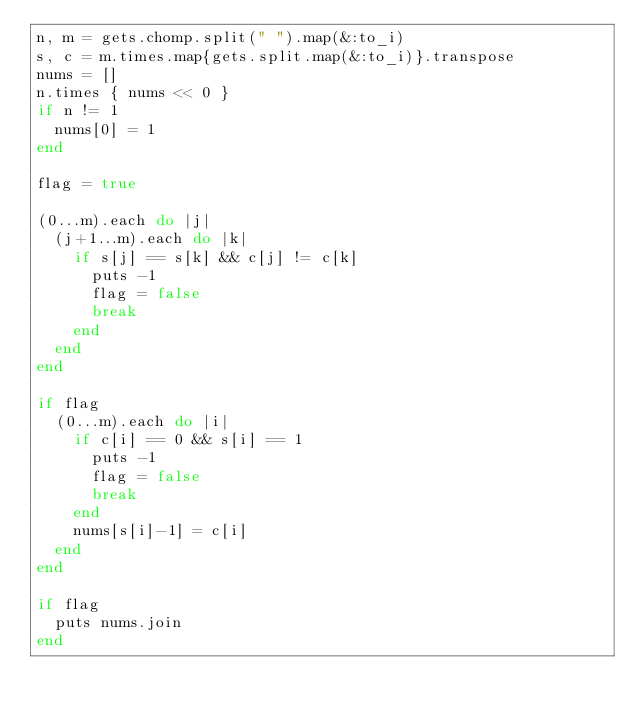<code> <loc_0><loc_0><loc_500><loc_500><_Ruby_>n, m = gets.chomp.split(" ").map(&:to_i)
s, c = m.times.map{gets.split.map(&:to_i)}.transpose
nums = []
n.times { nums << 0 }
if n != 1
  nums[0] = 1
end

flag = true

(0...m).each do |j|
  (j+1...m).each do |k|
    if s[j] == s[k] && c[j] != c[k]
      puts -1
      flag = false
      break
    end
  end
end

if flag
  (0...m).each do |i|
    if c[i] == 0 && s[i] == 1 
      puts -1
      flag = false
      break
    end
    nums[s[i]-1] = c[i] 
  end
end

if flag
  puts nums.join
end</code> 